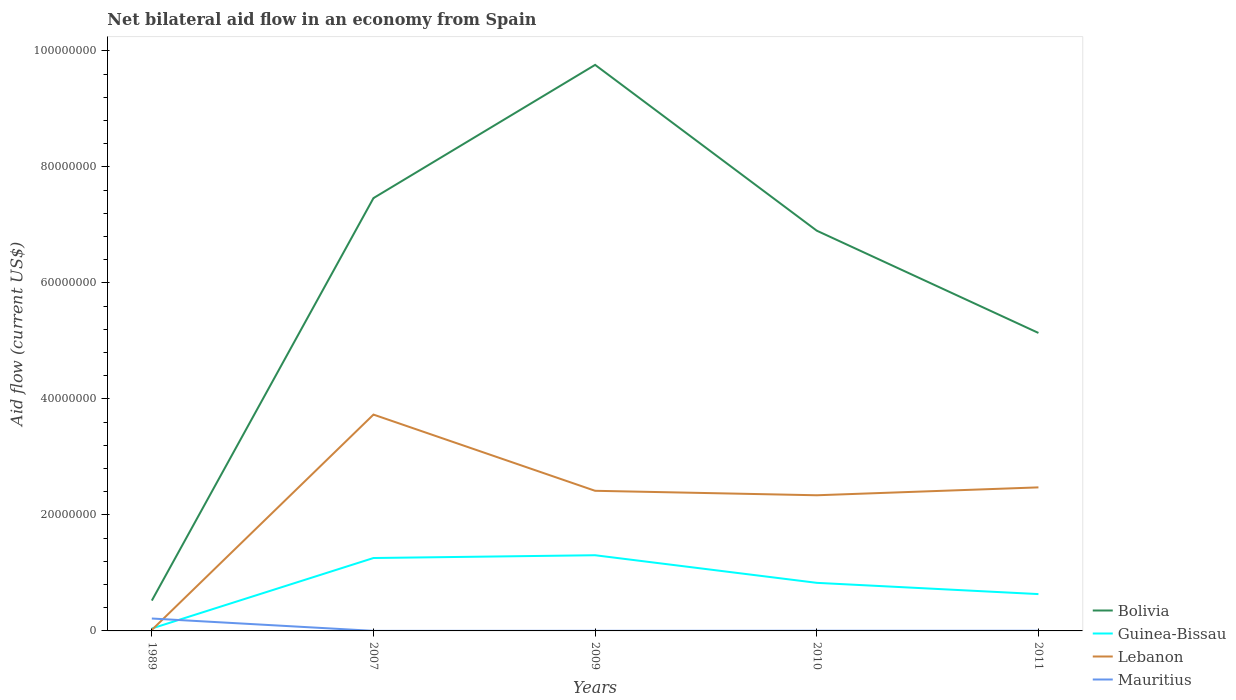Is the number of lines equal to the number of legend labels?
Provide a short and direct response. Yes. In which year was the net bilateral aid flow in Guinea-Bissau maximum?
Make the answer very short. 1989. What is the total net bilateral aid flow in Bolivia in the graph?
Keep it short and to the point. -6.38e+07. What is the difference between the highest and the second highest net bilateral aid flow in Guinea-Bissau?
Ensure brevity in your answer.  1.26e+07. What is the difference between the highest and the lowest net bilateral aid flow in Mauritius?
Ensure brevity in your answer.  1. How many lines are there?
Offer a very short reply. 4. What is the difference between two consecutive major ticks on the Y-axis?
Make the answer very short. 2.00e+07. Are the values on the major ticks of Y-axis written in scientific E-notation?
Provide a short and direct response. No. Does the graph contain any zero values?
Your response must be concise. No. How many legend labels are there?
Your answer should be very brief. 4. How are the legend labels stacked?
Offer a terse response. Vertical. What is the title of the graph?
Your answer should be very brief. Net bilateral aid flow in an economy from Spain. What is the label or title of the Y-axis?
Offer a terse response. Aid flow (current US$). What is the Aid flow (current US$) of Bolivia in 1989?
Your response must be concise. 5.23e+06. What is the Aid flow (current US$) in Lebanon in 1989?
Ensure brevity in your answer.  1.70e+05. What is the Aid flow (current US$) of Mauritius in 1989?
Your response must be concise. 2.14e+06. What is the Aid flow (current US$) in Bolivia in 2007?
Keep it short and to the point. 7.46e+07. What is the Aid flow (current US$) in Guinea-Bissau in 2007?
Offer a very short reply. 1.26e+07. What is the Aid flow (current US$) of Lebanon in 2007?
Offer a very short reply. 3.73e+07. What is the Aid flow (current US$) in Bolivia in 2009?
Offer a very short reply. 9.76e+07. What is the Aid flow (current US$) of Guinea-Bissau in 2009?
Provide a succinct answer. 1.30e+07. What is the Aid flow (current US$) of Lebanon in 2009?
Your response must be concise. 2.42e+07. What is the Aid flow (current US$) in Mauritius in 2009?
Your response must be concise. 2.00e+04. What is the Aid flow (current US$) of Bolivia in 2010?
Offer a terse response. 6.90e+07. What is the Aid flow (current US$) in Guinea-Bissau in 2010?
Provide a succinct answer. 8.29e+06. What is the Aid flow (current US$) in Lebanon in 2010?
Offer a terse response. 2.34e+07. What is the Aid flow (current US$) in Mauritius in 2010?
Make the answer very short. 3.00e+04. What is the Aid flow (current US$) of Bolivia in 2011?
Your answer should be compact. 5.14e+07. What is the Aid flow (current US$) of Guinea-Bissau in 2011?
Your response must be concise. 6.35e+06. What is the Aid flow (current US$) in Lebanon in 2011?
Provide a short and direct response. 2.48e+07. Across all years, what is the maximum Aid flow (current US$) of Bolivia?
Give a very brief answer. 9.76e+07. Across all years, what is the maximum Aid flow (current US$) in Guinea-Bissau?
Offer a terse response. 1.30e+07. Across all years, what is the maximum Aid flow (current US$) of Lebanon?
Give a very brief answer. 3.73e+07. Across all years, what is the maximum Aid flow (current US$) of Mauritius?
Give a very brief answer. 2.14e+06. Across all years, what is the minimum Aid flow (current US$) of Bolivia?
Provide a short and direct response. 5.23e+06. Across all years, what is the minimum Aid flow (current US$) in Mauritius?
Ensure brevity in your answer.  10000. What is the total Aid flow (current US$) of Bolivia in the graph?
Provide a short and direct response. 2.98e+08. What is the total Aid flow (current US$) of Guinea-Bissau in the graph?
Make the answer very short. 4.07e+07. What is the total Aid flow (current US$) of Lebanon in the graph?
Your answer should be very brief. 1.10e+08. What is the total Aid flow (current US$) of Mauritius in the graph?
Ensure brevity in your answer.  2.23e+06. What is the difference between the Aid flow (current US$) of Bolivia in 1989 and that in 2007?
Offer a very short reply. -6.94e+07. What is the difference between the Aid flow (current US$) of Guinea-Bissau in 1989 and that in 2007?
Ensure brevity in your answer.  -1.22e+07. What is the difference between the Aid flow (current US$) of Lebanon in 1989 and that in 2007?
Make the answer very short. -3.71e+07. What is the difference between the Aid flow (current US$) in Mauritius in 1989 and that in 2007?
Keep it short and to the point. 2.13e+06. What is the difference between the Aid flow (current US$) of Bolivia in 1989 and that in 2009?
Make the answer very short. -9.24e+07. What is the difference between the Aid flow (current US$) in Guinea-Bissau in 1989 and that in 2009?
Offer a very short reply. -1.26e+07. What is the difference between the Aid flow (current US$) in Lebanon in 1989 and that in 2009?
Your answer should be very brief. -2.40e+07. What is the difference between the Aid flow (current US$) of Mauritius in 1989 and that in 2009?
Your response must be concise. 2.12e+06. What is the difference between the Aid flow (current US$) of Bolivia in 1989 and that in 2010?
Your response must be concise. -6.38e+07. What is the difference between the Aid flow (current US$) in Guinea-Bissau in 1989 and that in 2010?
Your answer should be compact. -7.87e+06. What is the difference between the Aid flow (current US$) in Lebanon in 1989 and that in 2010?
Offer a terse response. -2.32e+07. What is the difference between the Aid flow (current US$) in Mauritius in 1989 and that in 2010?
Offer a terse response. 2.11e+06. What is the difference between the Aid flow (current US$) in Bolivia in 1989 and that in 2011?
Offer a very short reply. -4.62e+07. What is the difference between the Aid flow (current US$) in Guinea-Bissau in 1989 and that in 2011?
Offer a terse response. -5.93e+06. What is the difference between the Aid flow (current US$) in Lebanon in 1989 and that in 2011?
Your answer should be very brief. -2.46e+07. What is the difference between the Aid flow (current US$) of Mauritius in 1989 and that in 2011?
Provide a succinct answer. 2.11e+06. What is the difference between the Aid flow (current US$) in Bolivia in 2007 and that in 2009?
Ensure brevity in your answer.  -2.30e+07. What is the difference between the Aid flow (current US$) of Guinea-Bissau in 2007 and that in 2009?
Ensure brevity in your answer.  -4.80e+05. What is the difference between the Aid flow (current US$) of Lebanon in 2007 and that in 2009?
Provide a short and direct response. 1.31e+07. What is the difference between the Aid flow (current US$) of Bolivia in 2007 and that in 2010?
Make the answer very short. 5.62e+06. What is the difference between the Aid flow (current US$) in Guinea-Bissau in 2007 and that in 2010?
Your answer should be compact. 4.28e+06. What is the difference between the Aid flow (current US$) of Lebanon in 2007 and that in 2010?
Give a very brief answer. 1.39e+07. What is the difference between the Aid flow (current US$) in Mauritius in 2007 and that in 2010?
Your answer should be compact. -2.00e+04. What is the difference between the Aid flow (current US$) of Bolivia in 2007 and that in 2011?
Your answer should be very brief. 2.32e+07. What is the difference between the Aid flow (current US$) in Guinea-Bissau in 2007 and that in 2011?
Your answer should be compact. 6.22e+06. What is the difference between the Aid flow (current US$) in Lebanon in 2007 and that in 2011?
Keep it short and to the point. 1.26e+07. What is the difference between the Aid flow (current US$) in Mauritius in 2007 and that in 2011?
Give a very brief answer. -2.00e+04. What is the difference between the Aid flow (current US$) of Bolivia in 2009 and that in 2010?
Provide a short and direct response. 2.86e+07. What is the difference between the Aid flow (current US$) of Guinea-Bissau in 2009 and that in 2010?
Keep it short and to the point. 4.76e+06. What is the difference between the Aid flow (current US$) in Lebanon in 2009 and that in 2010?
Offer a terse response. 7.70e+05. What is the difference between the Aid flow (current US$) in Bolivia in 2009 and that in 2011?
Keep it short and to the point. 4.62e+07. What is the difference between the Aid flow (current US$) in Guinea-Bissau in 2009 and that in 2011?
Offer a very short reply. 6.70e+06. What is the difference between the Aid flow (current US$) in Lebanon in 2009 and that in 2011?
Ensure brevity in your answer.  -5.90e+05. What is the difference between the Aid flow (current US$) in Bolivia in 2010 and that in 2011?
Provide a succinct answer. 1.76e+07. What is the difference between the Aid flow (current US$) in Guinea-Bissau in 2010 and that in 2011?
Offer a terse response. 1.94e+06. What is the difference between the Aid flow (current US$) in Lebanon in 2010 and that in 2011?
Keep it short and to the point. -1.36e+06. What is the difference between the Aid flow (current US$) of Bolivia in 1989 and the Aid flow (current US$) of Guinea-Bissau in 2007?
Make the answer very short. -7.34e+06. What is the difference between the Aid flow (current US$) in Bolivia in 1989 and the Aid flow (current US$) in Lebanon in 2007?
Your answer should be very brief. -3.21e+07. What is the difference between the Aid flow (current US$) in Bolivia in 1989 and the Aid flow (current US$) in Mauritius in 2007?
Provide a short and direct response. 5.22e+06. What is the difference between the Aid flow (current US$) in Guinea-Bissau in 1989 and the Aid flow (current US$) in Lebanon in 2007?
Give a very brief answer. -3.69e+07. What is the difference between the Aid flow (current US$) of Guinea-Bissau in 1989 and the Aid flow (current US$) of Mauritius in 2007?
Provide a succinct answer. 4.10e+05. What is the difference between the Aid flow (current US$) in Bolivia in 1989 and the Aid flow (current US$) in Guinea-Bissau in 2009?
Your answer should be very brief. -7.82e+06. What is the difference between the Aid flow (current US$) in Bolivia in 1989 and the Aid flow (current US$) in Lebanon in 2009?
Your answer should be compact. -1.89e+07. What is the difference between the Aid flow (current US$) in Bolivia in 1989 and the Aid flow (current US$) in Mauritius in 2009?
Your response must be concise. 5.21e+06. What is the difference between the Aid flow (current US$) in Guinea-Bissau in 1989 and the Aid flow (current US$) in Lebanon in 2009?
Make the answer very short. -2.37e+07. What is the difference between the Aid flow (current US$) of Guinea-Bissau in 1989 and the Aid flow (current US$) of Mauritius in 2009?
Make the answer very short. 4.00e+05. What is the difference between the Aid flow (current US$) in Bolivia in 1989 and the Aid flow (current US$) in Guinea-Bissau in 2010?
Your response must be concise. -3.06e+06. What is the difference between the Aid flow (current US$) in Bolivia in 1989 and the Aid flow (current US$) in Lebanon in 2010?
Make the answer very short. -1.82e+07. What is the difference between the Aid flow (current US$) in Bolivia in 1989 and the Aid flow (current US$) in Mauritius in 2010?
Ensure brevity in your answer.  5.20e+06. What is the difference between the Aid flow (current US$) of Guinea-Bissau in 1989 and the Aid flow (current US$) of Lebanon in 2010?
Make the answer very short. -2.30e+07. What is the difference between the Aid flow (current US$) of Guinea-Bissau in 1989 and the Aid flow (current US$) of Mauritius in 2010?
Offer a terse response. 3.90e+05. What is the difference between the Aid flow (current US$) of Lebanon in 1989 and the Aid flow (current US$) of Mauritius in 2010?
Make the answer very short. 1.40e+05. What is the difference between the Aid flow (current US$) in Bolivia in 1989 and the Aid flow (current US$) in Guinea-Bissau in 2011?
Provide a succinct answer. -1.12e+06. What is the difference between the Aid flow (current US$) in Bolivia in 1989 and the Aid flow (current US$) in Lebanon in 2011?
Your response must be concise. -1.95e+07. What is the difference between the Aid flow (current US$) in Bolivia in 1989 and the Aid flow (current US$) in Mauritius in 2011?
Provide a short and direct response. 5.20e+06. What is the difference between the Aid flow (current US$) of Guinea-Bissau in 1989 and the Aid flow (current US$) of Lebanon in 2011?
Make the answer very short. -2.43e+07. What is the difference between the Aid flow (current US$) in Lebanon in 1989 and the Aid flow (current US$) in Mauritius in 2011?
Provide a succinct answer. 1.40e+05. What is the difference between the Aid flow (current US$) of Bolivia in 2007 and the Aid flow (current US$) of Guinea-Bissau in 2009?
Offer a terse response. 6.16e+07. What is the difference between the Aid flow (current US$) in Bolivia in 2007 and the Aid flow (current US$) in Lebanon in 2009?
Provide a succinct answer. 5.05e+07. What is the difference between the Aid flow (current US$) in Bolivia in 2007 and the Aid flow (current US$) in Mauritius in 2009?
Provide a succinct answer. 7.46e+07. What is the difference between the Aid flow (current US$) of Guinea-Bissau in 2007 and the Aid flow (current US$) of Lebanon in 2009?
Give a very brief answer. -1.16e+07. What is the difference between the Aid flow (current US$) in Guinea-Bissau in 2007 and the Aid flow (current US$) in Mauritius in 2009?
Ensure brevity in your answer.  1.26e+07. What is the difference between the Aid flow (current US$) of Lebanon in 2007 and the Aid flow (current US$) of Mauritius in 2009?
Offer a terse response. 3.73e+07. What is the difference between the Aid flow (current US$) in Bolivia in 2007 and the Aid flow (current US$) in Guinea-Bissau in 2010?
Offer a very short reply. 6.63e+07. What is the difference between the Aid flow (current US$) in Bolivia in 2007 and the Aid flow (current US$) in Lebanon in 2010?
Provide a short and direct response. 5.12e+07. What is the difference between the Aid flow (current US$) of Bolivia in 2007 and the Aid flow (current US$) of Mauritius in 2010?
Ensure brevity in your answer.  7.46e+07. What is the difference between the Aid flow (current US$) in Guinea-Bissau in 2007 and the Aid flow (current US$) in Lebanon in 2010?
Your answer should be very brief. -1.08e+07. What is the difference between the Aid flow (current US$) in Guinea-Bissau in 2007 and the Aid flow (current US$) in Mauritius in 2010?
Provide a short and direct response. 1.25e+07. What is the difference between the Aid flow (current US$) of Lebanon in 2007 and the Aid flow (current US$) of Mauritius in 2010?
Your answer should be compact. 3.73e+07. What is the difference between the Aid flow (current US$) in Bolivia in 2007 and the Aid flow (current US$) in Guinea-Bissau in 2011?
Offer a very short reply. 6.83e+07. What is the difference between the Aid flow (current US$) of Bolivia in 2007 and the Aid flow (current US$) of Lebanon in 2011?
Keep it short and to the point. 4.99e+07. What is the difference between the Aid flow (current US$) of Bolivia in 2007 and the Aid flow (current US$) of Mauritius in 2011?
Your answer should be compact. 7.46e+07. What is the difference between the Aid flow (current US$) in Guinea-Bissau in 2007 and the Aid flow (current US$) in Lebanon in 2011?
Your answer should be compact. -1.22e+07. What is the difference between the Aid flow (current US$) in Guinea-Bissau in 2007 and the Aid flow (current US$) in Mauritius in 2011?
Ensure brevity in your answer.  1.25e+07. What is the difference between the Aid flow (current US$) in Lebanon in 2007 and the Aid flow (current US$) in Mauritius in 2011?
Keep it short and to the point. 3.73e+07. What is the difference between the Aid flow (current US$) of Bolivia in 2009 and the Aid flow (current US$) of Guinea-Bissau in 2010?
Give a very brief answer. 8.93e+07. What is the difference between the Aid flow (current US$) in Bolivia in 2009 and the Aid flow (current US$) in Lebanon in 2010?
Offer a terse response. 7.42e+07. What is the difference between the Aid flow (current US$) in Bolivia in 2009 and the Aid flow (current US$) in Mauritius in 2010?
Ensure brevity in your answer.  9.76e+07. What is the difference between the Aid flow (current US$) of Guinea-Bissau in 2009 and the Aid flow (current US$) of Lebanon in 2010?
Ensure brevity in your answer.  -1.03e+07. What is the difference between the Aid flow (current US$) of Guinea-Bissau in 2009 and the Aid flow (current US$) of Mauritius in 2010?
Provide a short and direct response. 1.30e+07. What is the difference between the Aid flow (current US$) in Lebanon in 2009 and the Aid flow (current US$) in Mauritius in 2010?
Make the answer very short. 2.41e+07. What is the difference between the Aid flow (current US$) in Bolivia in 2009 and the Aid flow (current US$) in Guinea-Bissau in 2011?
Your response must be concise. 9.12e+07. What is the difference between the Aid flow (current US$) in Bolivia in 2009 and the Aid flow (current US$) in Lebanon in 2011?
Your answer should be compact. 7.28e+07. What is the difference between the Aid flow (current US$) in Bolivia in 2009 and the Aid flow (current US$) in Mauritius in 2011?
Your answer should be compact. 9.76e+07. What is the difference between the Aid flow (current US$) in Guinea-Bissau in 2009 and the Aid flow (current US$) in Lebanon in 2011?
Your response must be concise. -1.17e+07. What is the difference between the Aid flow (current US$) in Guinea-Bissau in 2009 and the Aid flow (current US$) in Mauritius in 2011?
Your response must be concise. 1.30e+07. What is the difference between the Aid flow (current US$) in Lebanon in 2009 and the Aid flow (current US$) in Mauritius in 2011?
Your answer should be very brief. 2.41e+07. What is the difference between the Aid flow (current US$) of Bolivia in 2010 and the Aid flow (current US$) of Guinea-Bissau in 2011?
Provide a short and direct response. 6.27e+07. What is the difference between the Aid flow (current US$) of Bolivia in 2010 and the Aid flow (current US$) of Lebanon in 2011?
Give a very brief answer. 4.43e+07. What is the difference between the Aid flow (current US$) of Bolivia in 2010 and the Aid flow (current US$) of Mauritius in 2011?
Provide a succinct answer. 6.90e+07. What is the difference between the Aid flow (current US$) of Guinea-Bissau in 2010 and the Aid flow (current US$) of Lebanon in 2011?
Keep it short and to the point. -1.65e+07. What is the difference between the Aid flow (current US$) of Guinea-Bissau in 2010 and the Aid flow (current US$) of Mauritius in 2011?
Your response must be concise. 8.26e+06. What is the difference between the Aid flow (current US$) in Lebanon in 2010 and the Aid flow (current US$) in Mauritius in 2011?
Ensure brevity in your answer.  2.34e+07. What is the average Aid flow (current US$) in Bolivia per year?
Offer a terse response. 5.96e+07. What is the average Aid flow (current US$) of Guinea-Bissau per year?
Give a very brief answer. 8.14e+06. What is the average Aid flow (current US$) of Lebanon per year?
Give a very brief answer. 2.20e+07. What is the average Aid flow (current US$) of Mauritius per year?
Your response must be concise. 4.46e+05. In the year 1989, what is the difference between the Aid flow (current US$) of Bolivia and Aid flow (current US$) of Guinea-Bissau?
Keep it short and to the point. 4.81e+06. In the year 1989, what is the difference between the Aid flow (current US$) of Bolivia and Aid flow (current US$) of Lebanon?
Offer a very short reply. 5.06e+06. In the year 1989, what is the difference between the Aid flow (current US$) in Bolivia and Aid flow (current US$) in Mauritius?
Ensure brevity in your answer.  3.09e+06. In the year 1989, what is the difference between the Aid flow (current US$) in Guinea-Bissau and Aid flow (current US$) in Lebanon?
Your response must be concise. 2.50e+05. In the year 1989, what is the difference between the Aid flow (current US$) in Guinea-Bissau and Aid flow (current US$) in Mauritius?
Ensure brevity in your answer.  -1.72e+06. In the year 1989, what is the difference between the Aid flow (current US$) of Lebanon and Aid flow (current US$) of Mauritius?
Give a very brief answer. -1.97e+06. In the year 2007, what is the difference between the Aid flow (current US$) of Bolivia and Aid flow (current US$) of Guinea-Bissau?
Make the answer very short. 6.21e+07. In the year 2007, what is the difference between the Aid flow (current US$) in Bolivia and Aid flow (current US$) in Lebanon?
Provide a succinct answer. 3.73e+07. In the year 2007, what is the difference between the Aid flow (current US$) in Bolivia and Aid flow (current US$) in Mauritius?
Ensure brevity in your answer.  7.46e+07. In the year 2007, what is the difference between the Aid flow (current US$) in Guinea-Bissau and Aid flow (current US$) in Lebanon?
Provide a succinct answer. -2.47e+07. In the year 2007, what is the difference between the Aid flow (current US$) of Guinea-Bissau and Aid flow (current US$) of Mauritius?
Offer a very short reply. 1.26e+07. In the year 2007, what is the difference between the Aid flow (current US$) in Lebanon and Aid flow (current US$) in Mauritius?
Provide a succinct answer. 3.73e+07. In the year 2009, what is the difference between the Aid flow (current US$) of Bolivia and Aid flow (current US$) of Guinea-Bissau?
Provide a short and direct response. 8.46e+07. In the year 2009, what is the difference between the Aid flow (current US$) of Bolivia and Aid flow (current US$) of Lebanon?
Keep it short and to the point. 7.34e+07. In the year 2009, what is the difference between the Aid flow (current US$) of Bolivia and Aid flow (current US$) of Mauritius?
Give a very brief answer. 9.76e+07. In the year 2009, what is the difference between the Aid flow (current US$) in Guinea-Bissau and Aid flow (current US$) in Lebanon?
Provide a succinct answer. -1.11e+07. In the year 2009, what is the difference between the Aid flow (current US$) of Guinea-Bissau and Aid flow (current US$) of Mauritius?
Make the answer very short. 1.30e+07. In the year 2009, what is the difference between the Aid flow (current US$) in Lebanon and Aid flow (current US$) in Mauritius?
Ensure brevity in your answer.  2.41e+07. In the year 2010, what is the difference between the Aid flow (current US$) in Bolivia and Aid flow (current US$) in Guinea-Bissau?
Make the answer very short. 6.07e+07. In the year 2010, what is the difference between the Aid flow (current US$) of Bolivia and Aid flow (current US$) of Lebanon?
Provide a short and direct response. 4.56e+07. In the year 2010, what is the difference between the Aid flow (current US$) of Bolivia and Aid flow (current US$) of Mauritius?
Provide a short and direct response. 6.90e+07. In the year 2010, what is the difference between the Aid flow (current US$) of Guinea-Bissau and Aid flow (current US$) of Lebanon?
Provide a succinct answer. -1.51e+07. In the year 2010, what is the difference between the Aid flow (current US$) in Guinea-Bissau and Aid flow (current US$) in Mauritius?
Offer a terse response. 8.26e+06. In the year 2010, what is the difference between the Aid flow (current US$) of Lebanon and Aid flow (current US$) of Mauritius?
Give a very brief answer. 2.34e+07. In the year 2011, what is the difference between the Aid flow (current US$) of Bolivia and Aid flow (current US$) of Guinea-Bissau?
Your answer should be very brief. 4.50e+07. In the year 2011, what is the difference between the Aid flow (current US$) of Bolivia and Aid flow (current US$) of Lebanon?
Keep it short and to the point. 2.66e+07. In the year 2011, what is the difference between the Aid flow (current US$) in Bolivia and Aid flow (current US$) in Mauritius?
Your response must be concise. 5.14e+07. In the year 2011, what is the difference between the Aid flow (current US$) of Guinea-Bissau and Aid flow (current US$) of Lebanon?
Provide a succinct answer. -1.84e+07. In the year 2011, what is the difference between the Aid flow (current US$) of Guinea-Bissau and Aid flow (current US$) of Mauritius?
Your response must be concise. 6.32e+06. In the year 2011, what is the difference between the Aid flow (current US$) of Lebanon and Aid flow (current US$) of Mauritius?
Make the answer very short. 2.47e+07. What is the ratio of the Aid flow (current US$) of Bolivia in 1989 to that in 2007?
Your answer should be compact. 0.07. What is the ratio of the Aid flow (current US$) in Guinea-Bissau in 1989 to that in 2007?
Keep it short and to the point. 0.03. What is the ratio of the Aid flow (current US$) of Lebanon in 1989 to that in 2007?
Make the answer very short. 0. What is the ratio of the Aid flow (current US$) of Mauritius in 1989 to that in 2007?
Make the answer very short. 214. What is the ratio of the Aid flow (current US$) of Bolivia in 1989 to that in 2009?
Ensure brevity in your answer.  0.05. What is the ratio of the Aid flow (current US$) in Guinea-Bissau in 1989 to that in 2009?
Provide a succinct answer. 0.03. What is the ratio of the Aid flow (current US$) of Lebanon in 1989 to that in 2009?
Offer a very short reply. 0.01. What is the ratio of the Aid flow (current US$) in Mauritius in 1989 to that in 2009?
Make the answer very short. 107. What is the ratio of the Aid flow (current US$) in Bolivia in 1989 to that in 2010?
Make the answer very short. 0.08. What is the ratio of the Aid flow (current US$) of Guinea-Bissau in 1989 to that in 2010?
Make the answer very short. 0.05. What is the ratio of the Aid flow (current US$) of Lebanon in 1989 to that in 2010?
Keep it short and to the point. 0.01. What is the ratio of the Aid flow (current US$) of Mauritius in 1989 to that in 2010?
Provide a succinct answer. 71.33. What is the ratio of the Aid flow (current US$) of Bolivia in 1989 to that in 2011?
Your response must be concise. 0.1. What is the ratio of the Aid flow (current US$) of Guinea-Bissau in 1989 to that in 2011?
Offer a very short reply. 0.07. What is the ratio of the Aid flow (current US$) in Lebanon in 1989 to that in 2011?
Your response must be concise. 0.01. What is the ratio of the Aid flow (current US$) in Mauritius in 1989 to that in 2011?
Your answer should be very brief. 71.33. What is the ratio of the Aid flow (current US$) of Bolivia in 2007 to that in 2009?
Give a very brief answer. 0.76. What is the ratio of the Aid flow (current US$) of Guinea-Bissau in 2007 to that in 2009?
Ensure brevity in your answer.  0.96. What is the ratio of the Aid flow (current US$) of Lebanon in 2007 to that in 2009?
Offer a terse response. 1.54. What is the ratio of the Aid flow (current US$) in Mauritius in 2007 to that in 2009?
Your answer should be very brief. 0.5. What is the ratio of the Aid flow (current US$) in Bolivia in 2007 to that in 2010?
Your answer should be compact. 1.08. What is the ratio of the Aid flow (current US$) of Guinea-Bissau in 2007 to that in 2010?
Make the answer very short. 1.52. What is the ratio of the Aid flow (current US$) in Lebanon in 2007 to that in 2010?
Make the answer very short. 1.59. What is the ratio of the Aid flow (current US$) in Mauritius in 2007 to that in 2010?
Provide a short and direct response. 0.33. What is the ratio of the Aid flow (current US$) in Bolivia in 2007 to that in 2011?
Provide a succinct answer. 1.45. What is the ratio of the Aid flow (current US$) in Guinea-Bissau in 2007 to that in 2011?
Offer a terse response. 1.98. What is the ratio of the Aid flow (current US$) in Lebanon in 2007 to that in 2011?
Make the answer very short. 1.51. What is the ratio of the Aid flow (current US$) in Bolivia in 2009 to that in 2010?
Make the answer very short. 1.41. What is the ratio of the Aid flow (current US$) in Guinea-Bissau in 2009 to that in 2010?
Your answer should be compact. 1.57. What is the ratio of the Aid flow (current US$) of Lebanon in 2009 to that in 2010?
Provide a short and direct response. 1.03. What is the ratio of the Aid flow (current US$) in Bolivia in 2009 to that in 2011?
Provide a short and direct response. 1.9. What is the ratio of the Aid flow (current US$) in Guinea-Bissau in 2009 to that in 2011?
Provide a succinct answer. 2.06. What is the ratio of the Aid flow (current US$) of Lebanon in 2009 to that in 2011?
Make the answer very short. 0.98. What is the ratio of the Aid flow (current US$) of Mauritius in 2009 to that in 2011?
Offer a very short reply. 0.67. What is the ratio of the Aid flow (current US$) in Bolivia in 2010 to that in 2011?
Offer a terse response. 1.34. What is the ratio of the Aid flow (current US$) in Guinea-Bissau in 2010 to that in 2011?
Give a very brief answer. 1.31. What is the ratio of the Aid flow (current US$) in Lebanon in 2010 to that in 2011?
Offer a very short reply. 0.95. What is the difference between the highest and the second highest Aid flow (current US$) of Bolivia?
Ensure brevity in your answer.  2.30e+07. What is the difference between the highest and the second highest Aid flow (current US$) in Guinea-Bissau?
Keep it short and to the point. 4.80e+05. What is the difference between the highest and the second highest Aid flow (current US$) of Lebanon?
Give a very brief answer. 1.26e+07. What is the difference between the highest and the second highest Aid flow (current US$) of Mauritius?
Offer a very short reply. 2.11e+06. What is the difference between the highest and the lowest Aid flow (current US$) of Bolivia?
Your answer should be very brief. 9.24e+07. What is the difference between the highest and the lowest Aid flow (current US$) of Guinea-Bissau?
Keep it short and to the point. 1.26e+07. What is the difference between the highest and the lowest Aid flow (current US$) of Lebanon?
Offer a terse response. 3.71e+07. What is the difference between the highest and the lowest Aid flow (current US$) in Mauritius?
Make the answer very short. 2.13e+06. 